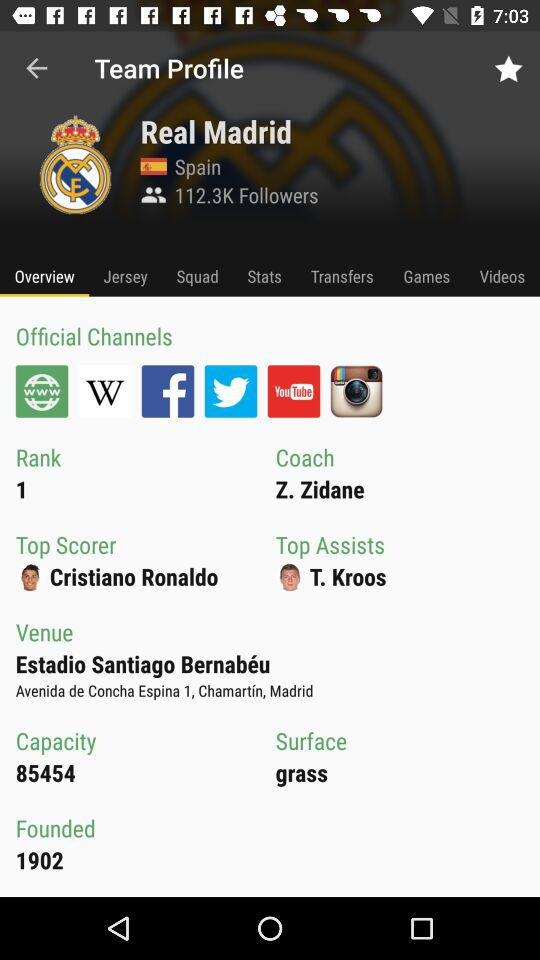Who are the official channel partners? The official channel partners are "Website", "Wikipedia", "Facebook", "Twitter", "Youtube" and "Instagram". 